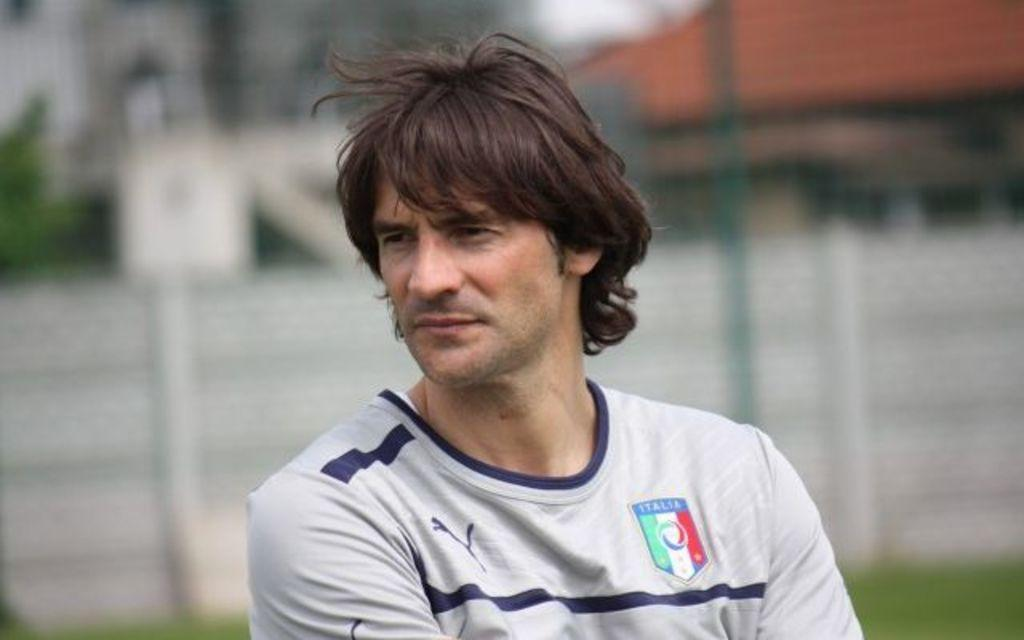<image>
Write a terse but informative summary of the picture. A man wearing a jersey that has an Italia patch. 